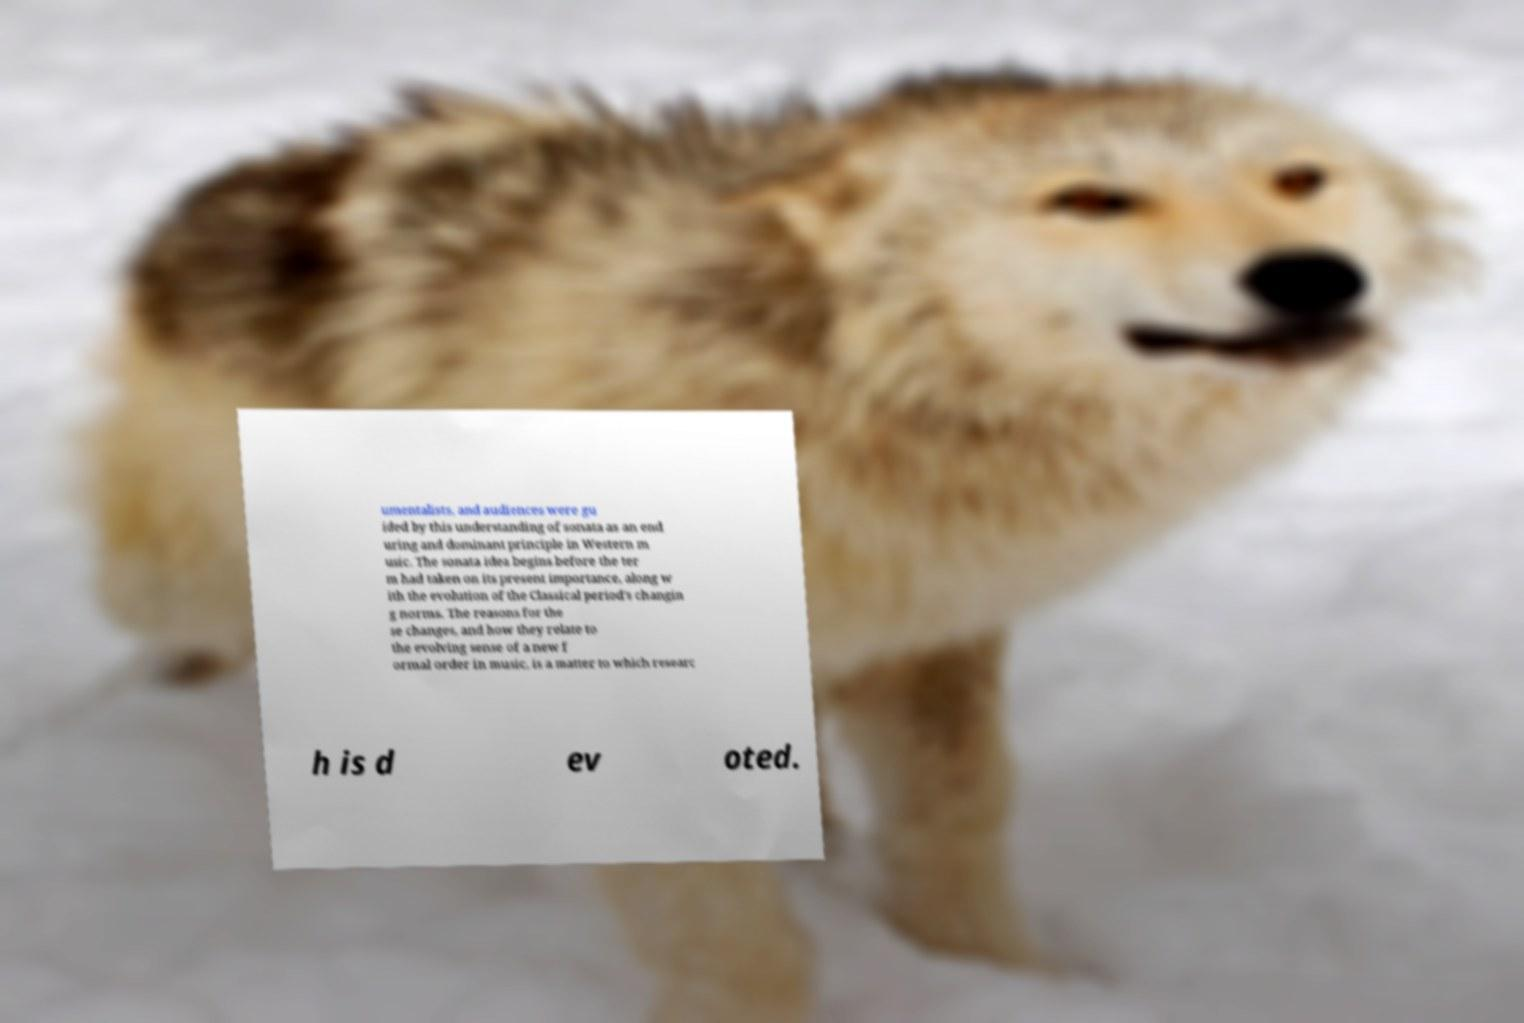Please read and relay the text visible in this image. What does it say? umentalists, and audiences were gu ided by this understanding of sonata as an end uring and dominant principle in Western m usic. The sonata idea begins before the ter m had taken on its present importance, along w ith the evolution of the Classical period's changin g norms. The reasons for the se changes, and how they relate to the evolving sense of a new f ormal order in music, is a matter to which researc h is d ev oted. 